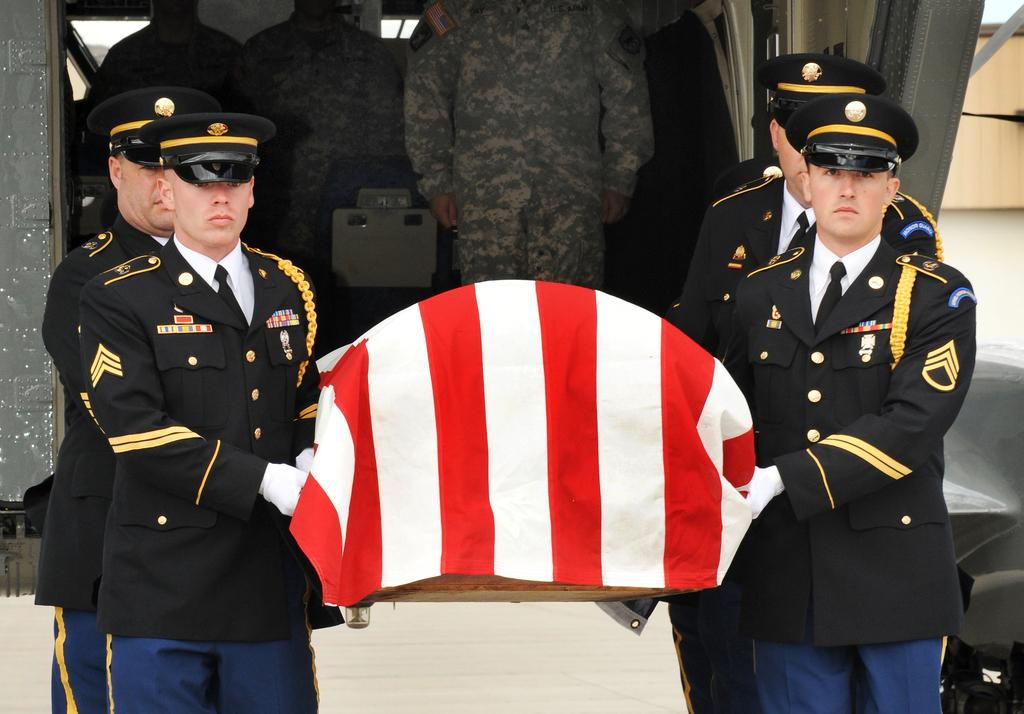What type of individuals are present in the image? There are officers in the image. What are the officers holding in their hands? The officers are holding objects. Can you describe the people inside the vehicle? There are people inside a vehicle in the image. What can be seen in the background of the image? There is a wall visible in the background of the image. How many wheels are visible on the vehicle in the image? The image does not show the vehicle's wheels, so it is not possible to determine the number of wheels. 